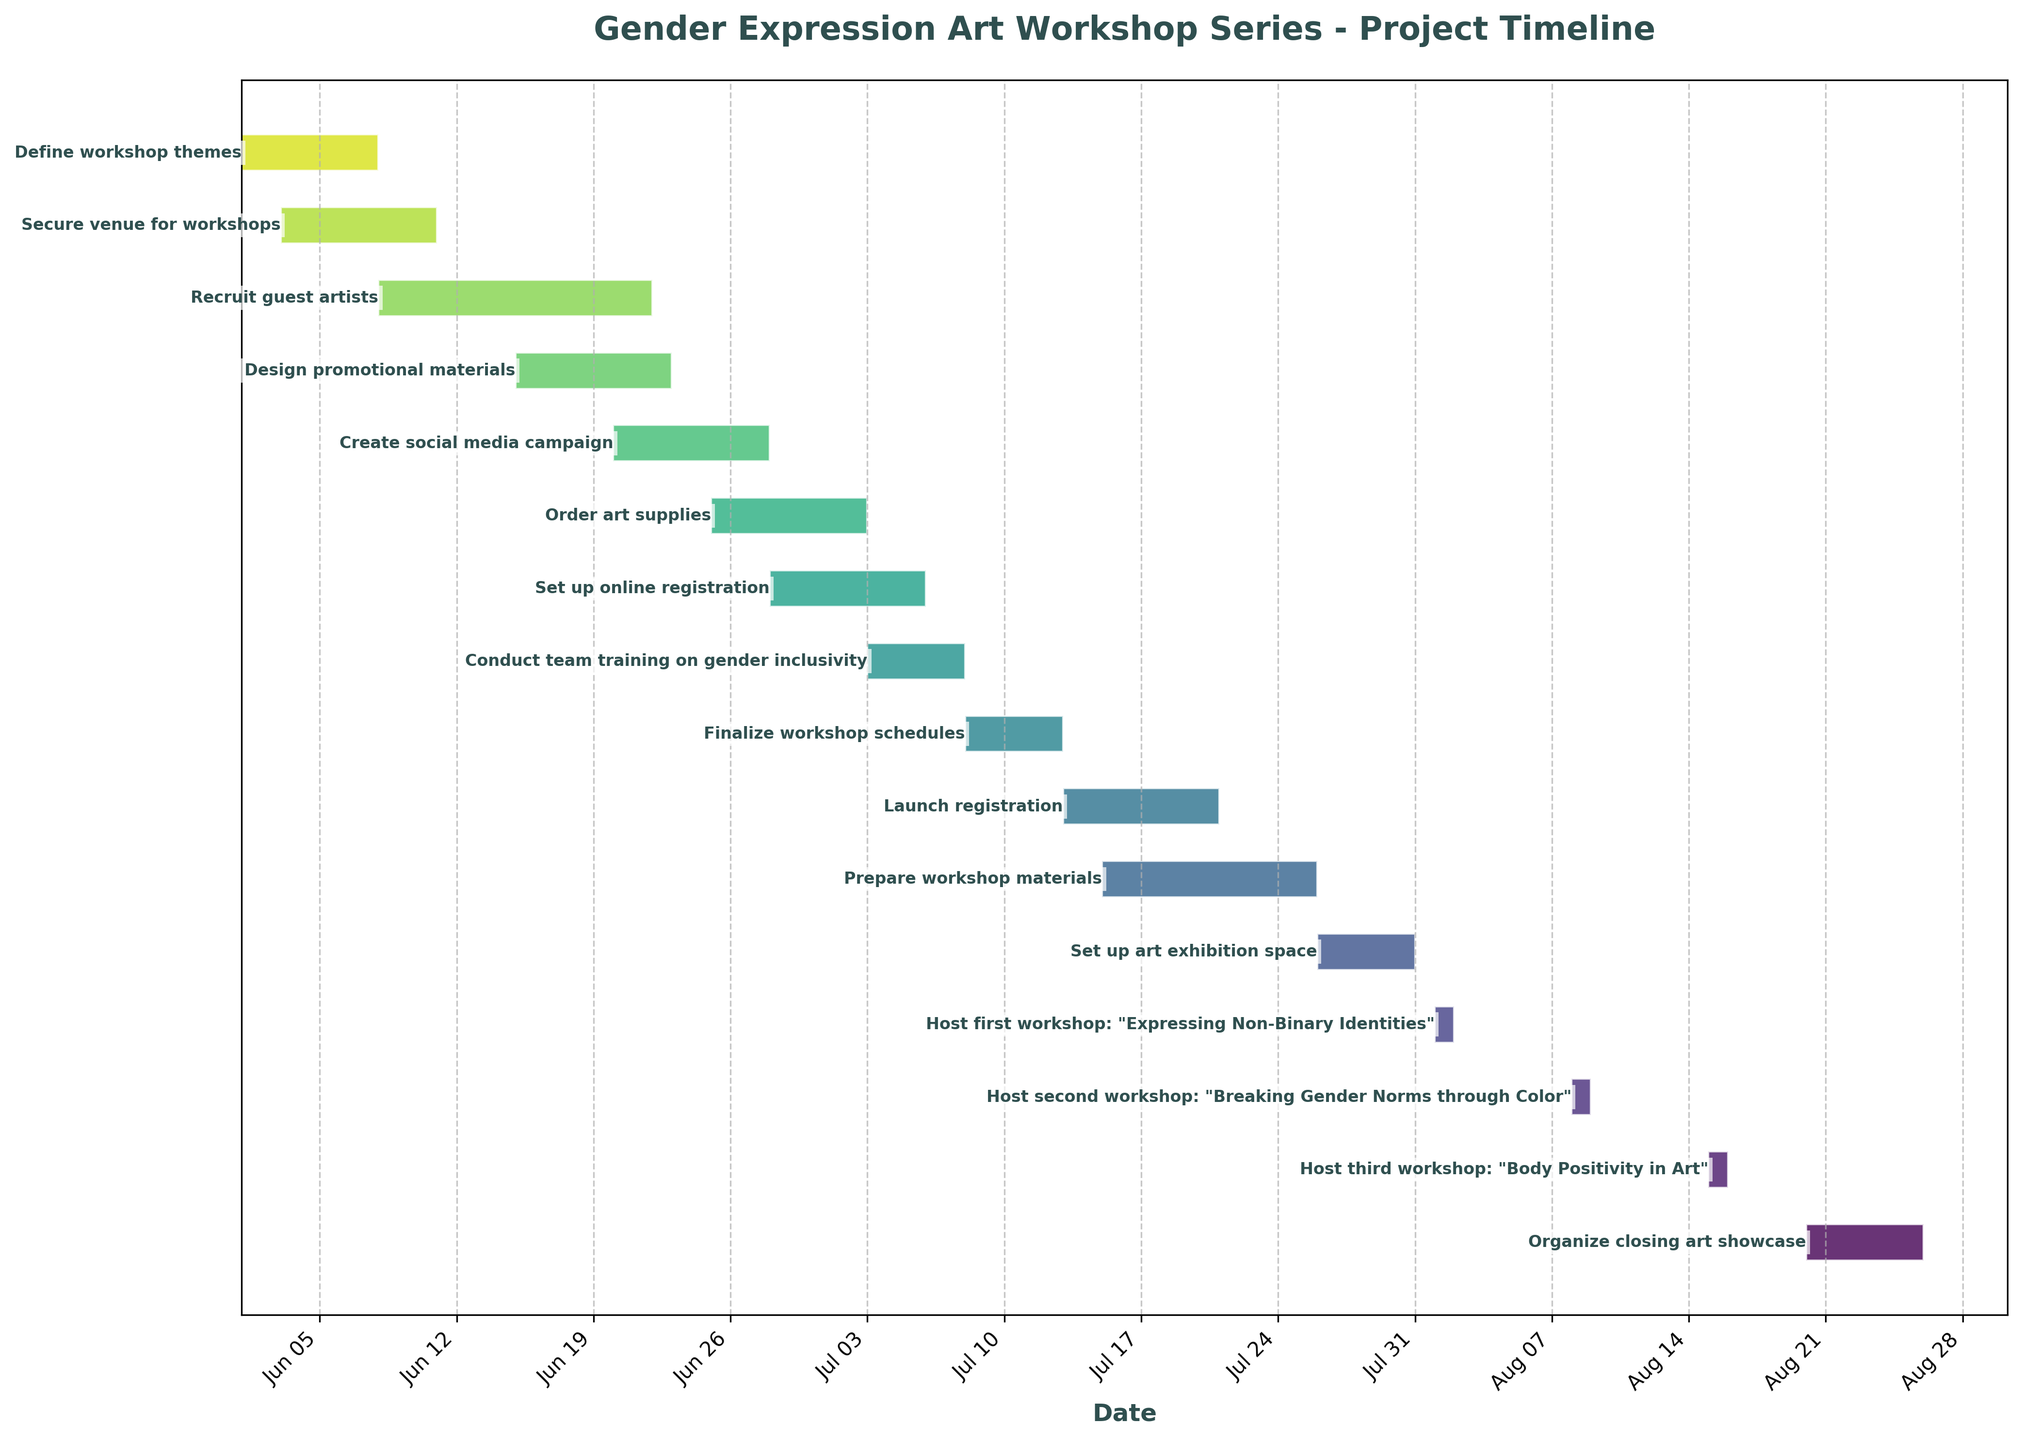what is the first task listed in the Gantt chart? The first task listed in the Gantt chart is the one that appears at the top of the list of bars. In this case, it is "Define workshop themes", which starts on June 1, 2023, and ends on June 7, 2023.
Answer: Define workshop themes When does the fourth task start and end? To find the fourth task, count the tasks from top to bottom and identify the start and end dates of the fourth one. The fourth task is "Design promotional materials", which starts on June 15, 2023, and ends on June 22, 2023.
Answer: June 15, 2023 — June 22, 2023 Which task has the longest duration and how many days does it last? Examine the duration column or the length of the bars in the Gantt chart to determine the longest task. The task "Recruit guest artists" has the longest duration, lasting 14 days.
Answer: Recruit guest artists — 14 days How many tasks overlap with the task "Design promotional materials"? Identify the time span of "Design promotional materials" (June 15 - June 22, 2023) and check which tasks overlap with these dates. The tasks that overlap are "Recruit guest artists" and "Create social media campaign".
Answer: 2 tasks overlap Are there any tasks happening on July 1, 2023? Check the Gantt chart to see which bars cover July 1, 2023. The tasks "Order art supplies" is ongoing on this date.
Answer: Order art supplies Which task starts immediately after "Set up online registration"? Look at the start date of "Set up online registration" (June 28 - July 5, 2023) and find the task that starts right after it ends. The task that starts immediately after is "Conduct team training on gender inclusivity" on July 3, 2023.
Answer: Conduct team training on gender inclusivity What is the average duration of tasks that start in June? Calculate the durations of all tasks starting in June and find the average. The tasks are "Define workshop themes (7 days)", "Secure venue for workshops (8 days)", "Recruit guest artists (14 days)", "Design promotional materials (8 days)", "Create social media campaign (8 days)", "Order art supplies (8 days)", "Set up online registration (8 days)". Average = (7 + 8 + 14 + 8 + 8 + 8 + 8) / 7 = 61 / 7 ≈ 8.7 days.
Answer: 8.7 days Which workshops are hosted in August and when do they occur? Check the Gantt chart for tasks labeled as workshops and note their dates in August. The workshops in August are "Expressing Non-Binary Identities" on August 1, "Breaking Gender Norms through Color" on August 8, and "Body Positivity in Art" on August 15.
Answer: August 1, August 8, August 15 When is the last task completed? Look at the Gantt chart and identify the ending date of the last task. The last task "Organize closing art showcase" ends on August 25, 2023.
Answer: August 25, 2023 